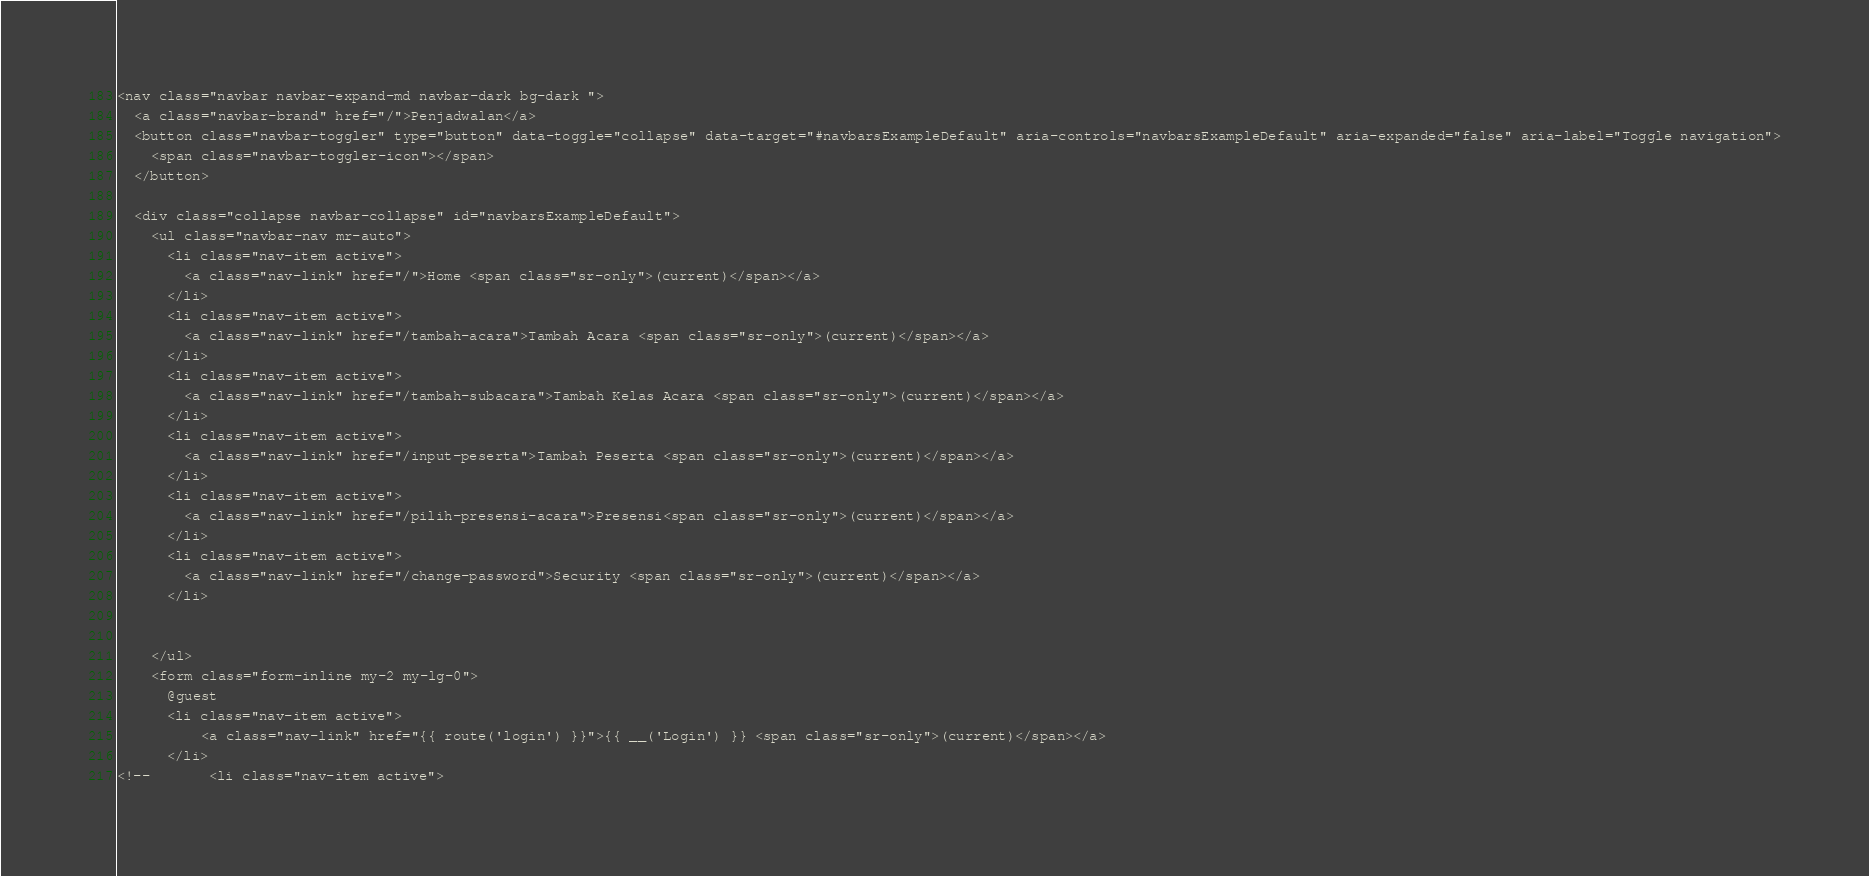<code> <loc_0><loc_0><loc_500><loc_500><_PHP_><nav class="navbar navbar-expand-md navbar-dark bg-dark ">
  <a class="navbar-brand" href="/">Penjadwalan</a>
  <button class="navbar-toggler" type="button" data-toggle="collapse" data-target="#navbarsExampleDefault" aria-controls="navbarsExampleDefault" aria-expanded="false" aria-label="Toggle navigation">
    <span class="navbar-toggler-icon"></span>
  </button>

  <div class="collapse navbar-collapse" id="navbarsExampleDefault">
    <ul class="navbar-nav mr-auto">
      <li class="nav-item active">
        <a class="nav-link" href="/">Home <span class="sr-only">(current)</span></a>
      </li>
      <li class="nav-item active">
        <a class="nav-link" href="/tambah-acara">Tambah Acara <span class="sr-only">(current)</span></a>
      </li>
      <li class="nav-item active">
        <a class="nav-link" href="/tambah-subacara">Tambah Kelas Acara <span class="sr-only">(current)</span></a>
      </li>
      <li class="nav-item active">
        <a class="nav-link" href="/input-peserta">Tambah Peserta <span class="sr-only">(current)</span></a>
      </li>
      <li class="nav-item active">
        <a class="nav-link" href="/pilih-presensi-acara">Presensi<span class="sr-only">(current)</span></a>
      </li>
      <li class="nav-item active">
        <a class="nav-link" href="/change-password">Security <span class="sr-only">(current)</span></a>
      </li>


    </ul>
    <form class="form-inline my-2 my-lg-0">
      @guest
      <li class="nav-item active">
          <a class="nav-link" href="{{ route('login') }}">{{ __('Login') }} <span class="sr-only">(current)</span></a>
      </li>
<!--       <li class="nav-item active"></code> 